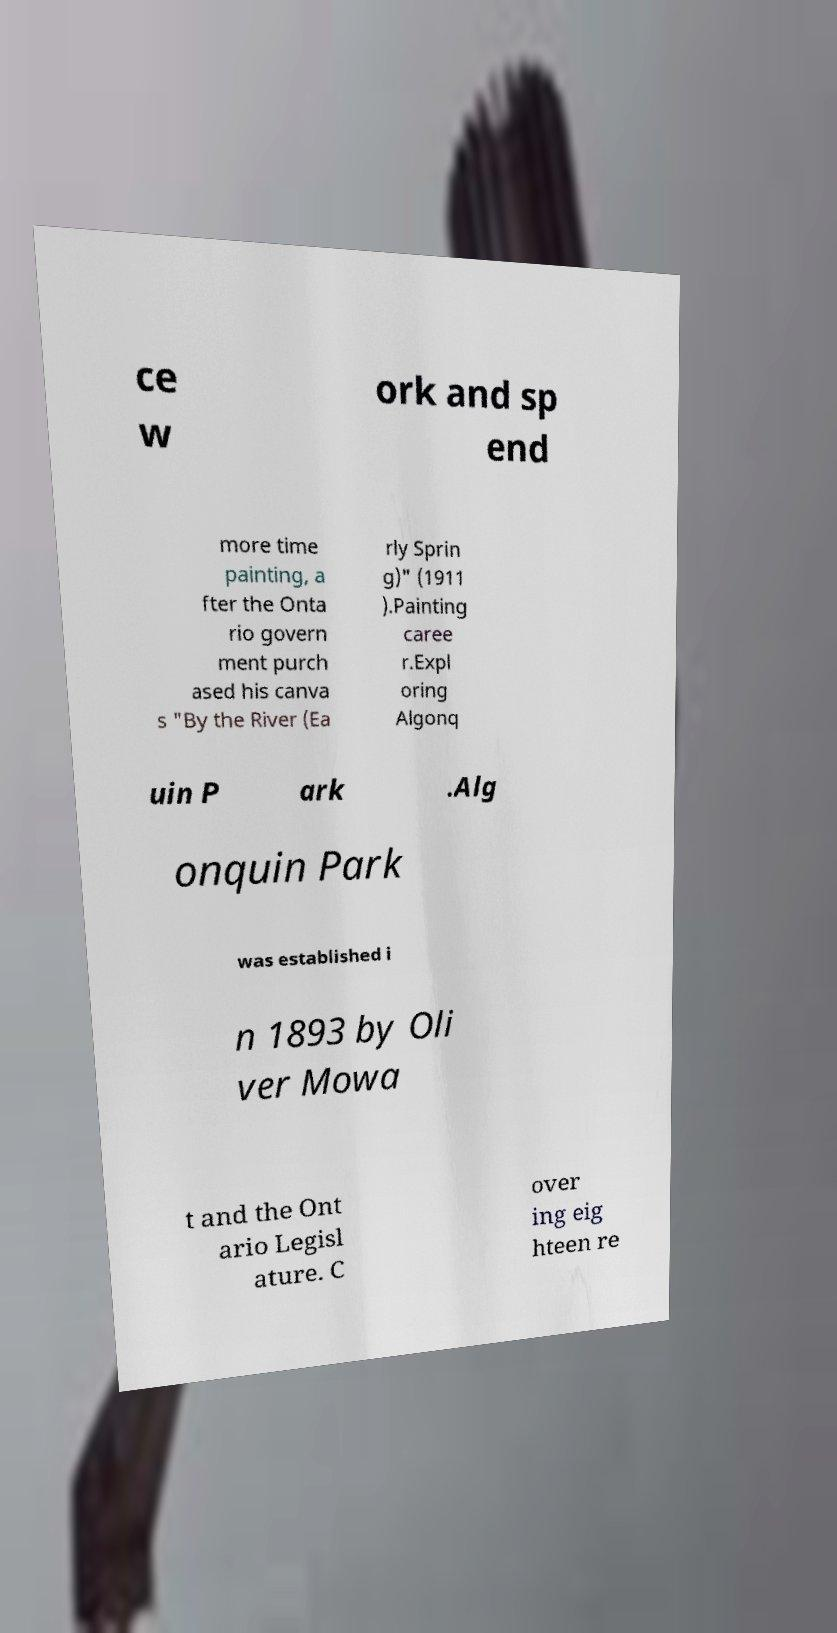Can you read and provide the text displayed in the image?This photo seems to have some interesting text. Can you extract and type it out for me? ce w ork and sp end more time painting, a fter the Onta rio govern ment purch ased his canva s "By the River (Ea rly Sprin g)" (1911 ).Painting caree r.Expl oring Algonq uin P ark .Alg onquin Park was established i n 1893 by Oli ver Mowa t and the Ont ario Legisl ature. C over ing eig hteen re 